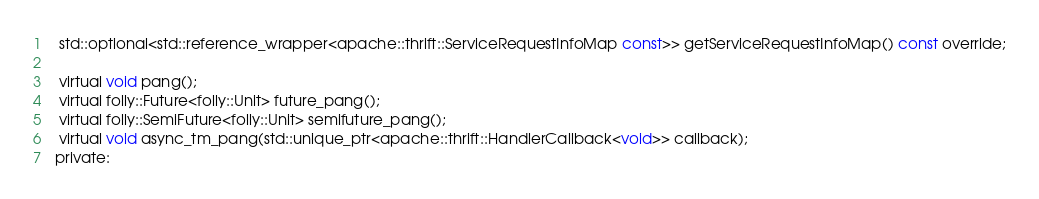<code> <loc_0><loc_0><loc_500><loc_500><_C_>  std::optional<std::reference_wrapper<apache::thrift::ServiceRequestInfoMap const>> getServiceRequestInfoMap() const override;

  virtual void pang();
  virtual folly::Future<folly::Unit> future_pang();
  virtual folly::SemiFuture<folly::Unit> semifuture_pang();
  virtual void async_tm_pang(std::unique_ptr<apache::thrift::HandlerCallback<void>> callback);
 private:</code> 